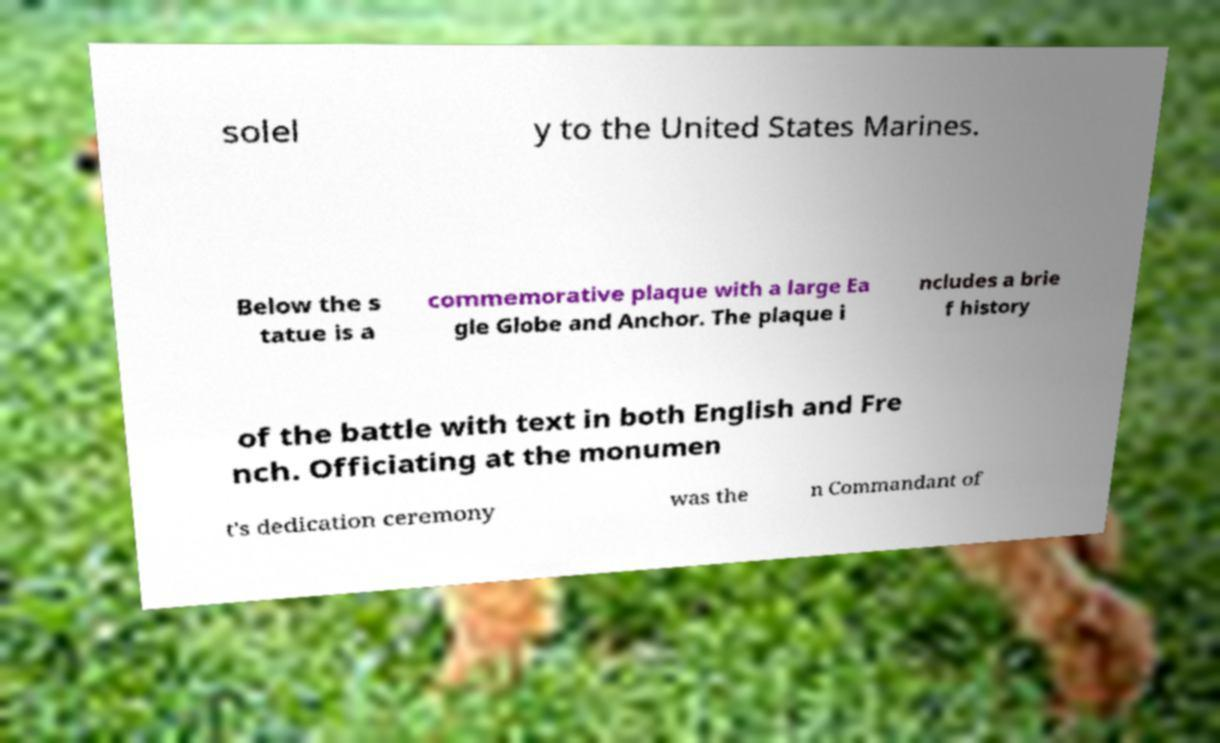Could you assist in decoding the text presented in this image and type it out clearly? solel y to the United States Marines. Below the s tatue is a commemorative plaque with a large Ea gle Globe and Anchor. The plaque i ncludes a brie f history of the battle with text in both English and Fre nch. Officiating at the monumen t's dedication ceremony was the n Commandant of 